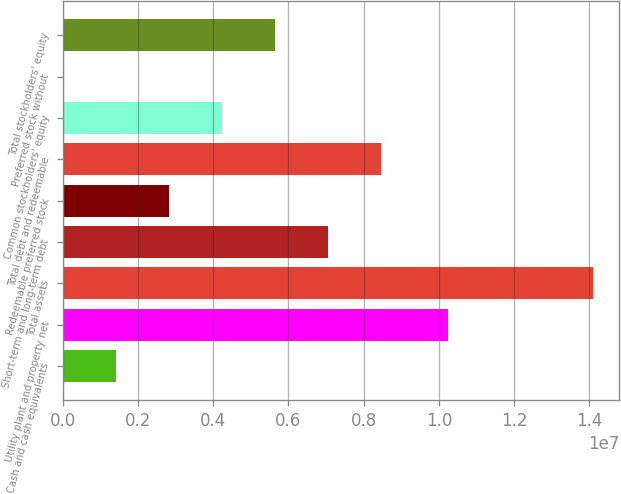Convert chart to OTSL. <chart><loc_0><loc_0><loc_500><loc_500><bar_chart><fcel>Cash and cash equivalents<fcel>Utility plant and property net<fcel>Total assets<fcel>Short-term and long-term debt<fcel>Redeemable preferred stock<fcel>Total debt and redeemable<fcel>Common stockholders' equity<fcel>Preferred stock without<fcel>Total stockholders' equity<nl><fcel>1.41272e+06<fcel>1.02413e+07<fcel>1.40862e+07<fcel>7.0454e+06<fcel>2.82089e+06<fcel>8.45357e+06<fcel>4.22906e+06<fcel>4547<fcel>5.63723e+06<nl></chart> 